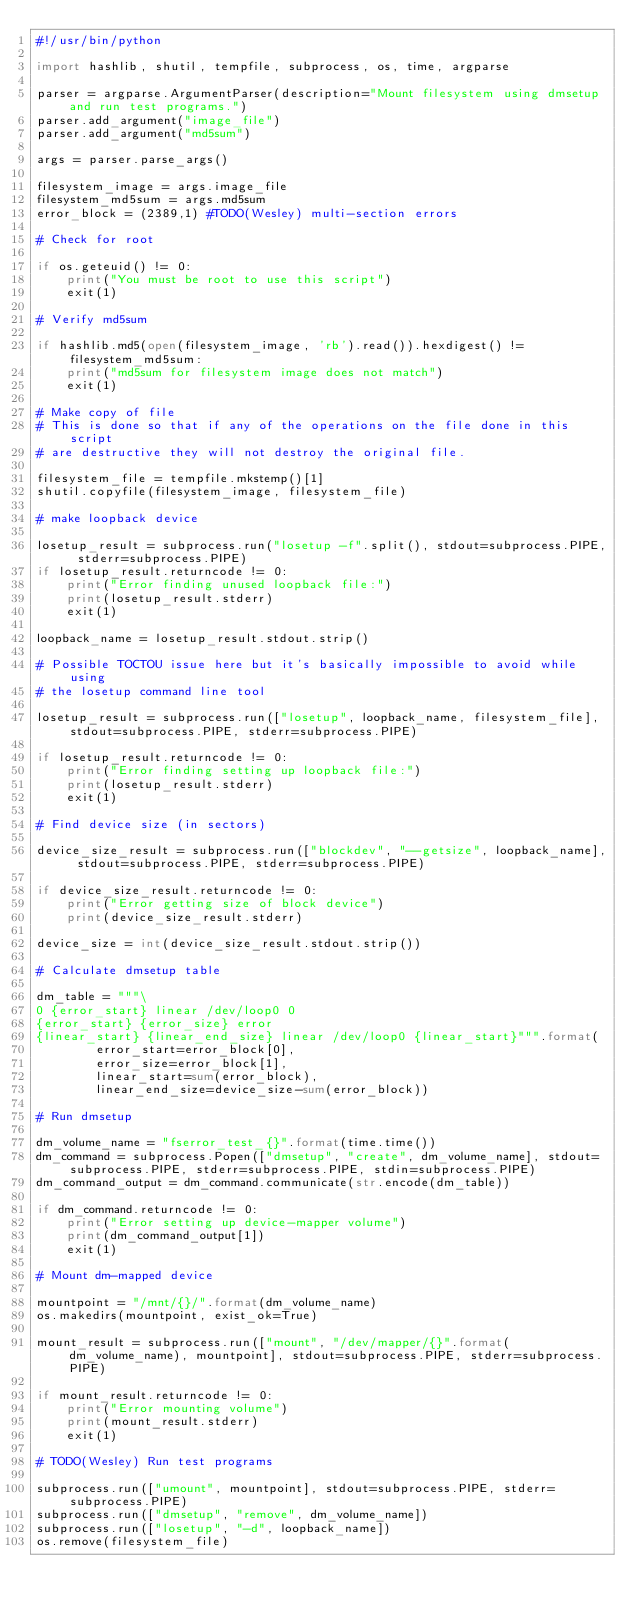Convert code to text. <code><loc_0><loc_0><loc_500><loc_500><_Python_>#!/usr/bin/python

import hashlib, shutil, tempfile, subprocess, os, time, argparse

parser = argparse.ArgumentParser(description="Mount filesystem using dmsetup and run test programs.")
parser.add_argument("image_file")
parser.add_argument("md5sum")

args = parser.parse_args()

filesystem_image = args.image_file
filesystem_md5sum = args.md5sum
error_block = (2389,1) #TODO(Wesley) multi-section errors

# Check for root

if os.geteuid() != 0:
    print("You must be root to use this script")
    exit(1)

# Verify md5sum

if hashlib.md5(open(filesystem_image, 'rb').read()).hexdigest() != filesystem_md5sum:
    print("md5sum for filesystem image does not match")
    exit(1)

# Make copy of file
# This is done so that if any of the operations on the file done in this script
# are destructive they will not destroy the original file.

filesystem_file = tempfile.mkstemp()[1]
shutil.copyfile(filesystem_image, filesystem_file)

# make loopback device

losetup_result = subprocess.run("losetup -f".split(), stdout=subprocess.PIPE, stderr=subprocess.PIPE)
if losetup_result.returncode != 0:
    print("Error finding unused loopback file:")
    print(losetup_result.stderr)
    exit(1)

loopback_name = losetup_result.stdout.strip()

# Possible TOCTOU issue here but it's basically impossible to avoid while using
# the losetup command line tool

losetup_result = subprocess.run(["losetup", loopback_name, filesystem_file], stdout=subprocess.PIPE, stderr=subprocess.PIPE)

if losetup_result.returncode != 0:
    print("Error finding setting up loopback file:")
    print(losetup_result.stderr)
    exit(1)

# Find device size (in sectors)

device_size_result = subprocess.run(["blockdev", "--getsize", loopback_name], stdout=subprocess.PIPE, stderr=subprocess.PIPE)

if device_size_result.returncode != 0:
    print("Error getting size of block device")
    print(device_size_result.stderr)

device_size = int(device_size_result.stdout.strip())

# Calculate dmsetup table

dm_table = """\
0 {error_start} linear /dev/loop0 0
{error_start} {error_size} error
{linear_start} {linear_end_size} linear /dev/loop0 {linear_start}""".format(
        error_start=error_block[0],
        error_size=error_block[1],
        linear_start=sum(error_block),
        linear_end_size=device_size-sum(error_block))

# Run dmsetup

dm_volume_name = "fserror_test_{}".format(time.time())
dm_command = subprocess.Popen(["dmsetup", "create", dm_volume_name], stdout=subprocess.PIPE, stderr=subprocess.PIPE, stdin=subprocess.PIPE)
dm_command_output = dm_command.communicate(str.encode(dm_table))

if dm_command.returncode != 0:
    print("Error setting up device-mapper volume")
    print(dm_command_output[1])
    exit(1)

# Mount dm-mapped device

mountpoint = "/mnt/{}/".format(dm_volume_name)
os.makedirs(mountpoint, exist_ok=True)

mount_result = subprocess.run(["mount", "/dev/mapper/{}".format(dm_volume_name), mountpoint], stdout=subprocess.PIPE, stderr=subprocess.PIPE)

if mount_result.returncode != 0:
    print("Error mounting volume")
    print(mount_result.stderr)
    exit(1)

# TODO(Wesley) Run test programs

subprocess.run(["umount", mountpoint], stdout=subprocess.PIPE, stderr=subprocess.PIPE)
subprocess.run(["dmsetup", "remove", dm_volume_name])
subprocess.run(["losetup", "-d", loopback_name])
os.remove(filesystem_file)
</code> 